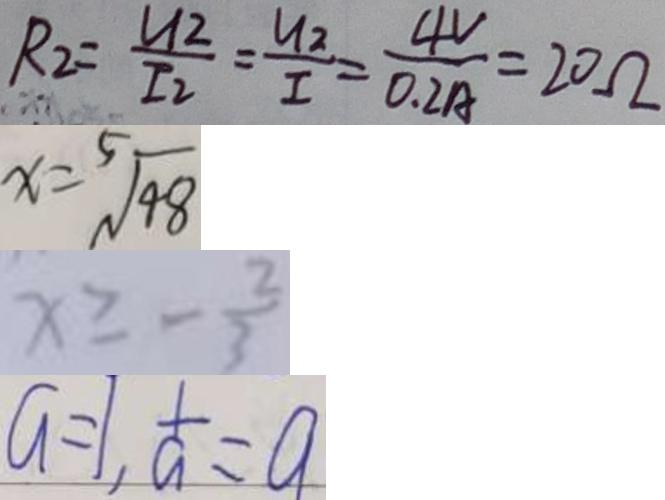Convert formula to latex. <formula><loc_0><loc_0><loc_500><loc_500>R _ { 2 } = \frac { u _ { 2 } } { I _ { 2 } } = \frac { u _ { 2 } } { I } = \frac { 4 V } { 0 . 2 A } = 2 0 \Omega 
 x = \sqrt [ 5 ] { 4 8 } 
 x \geq - \frac { 2 } { 3 } 
 a = 1 , \frac { 1 } { a } = a</formula> 